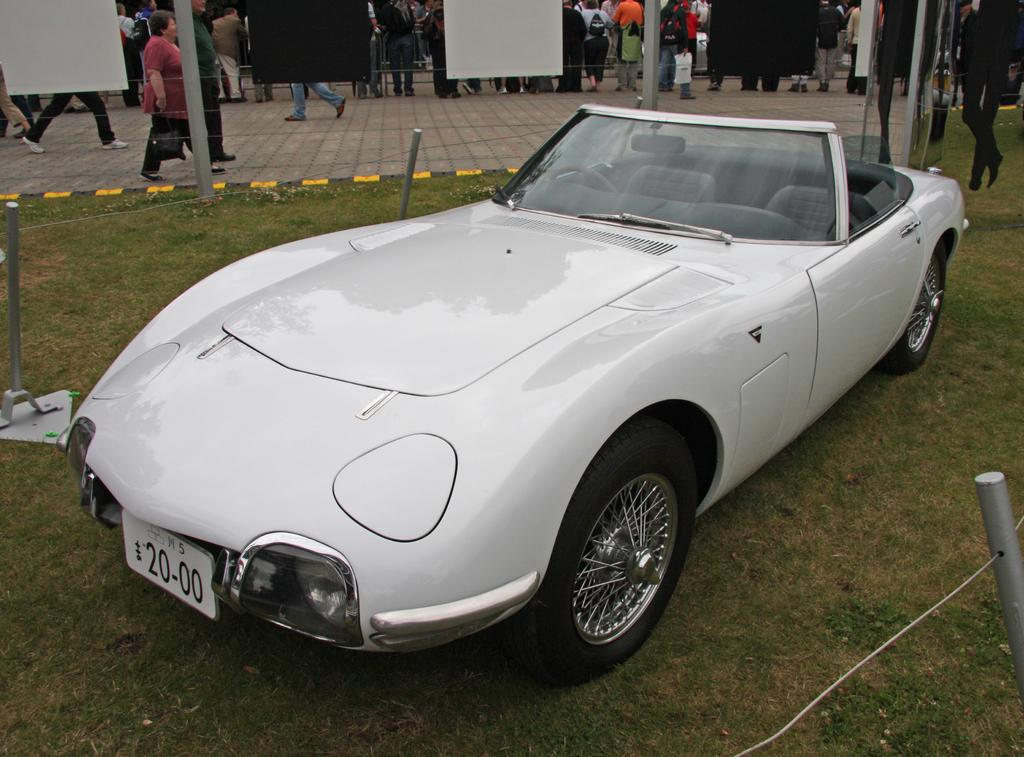What color is the car in the image? The car in the image is white. What type of vegetation can be seen in the image? There is grass visible in the image. What type of objects are hanging on the walls in the image? There are posters in the image. Can you describe the people present in the image? There are people present in the image, but their specific characteristics are not mentioned in the provided facts. How many cakes are being held by the people in the image? There is no mention of cakes in the image, so it cannot be determined if any are being held by the people. 